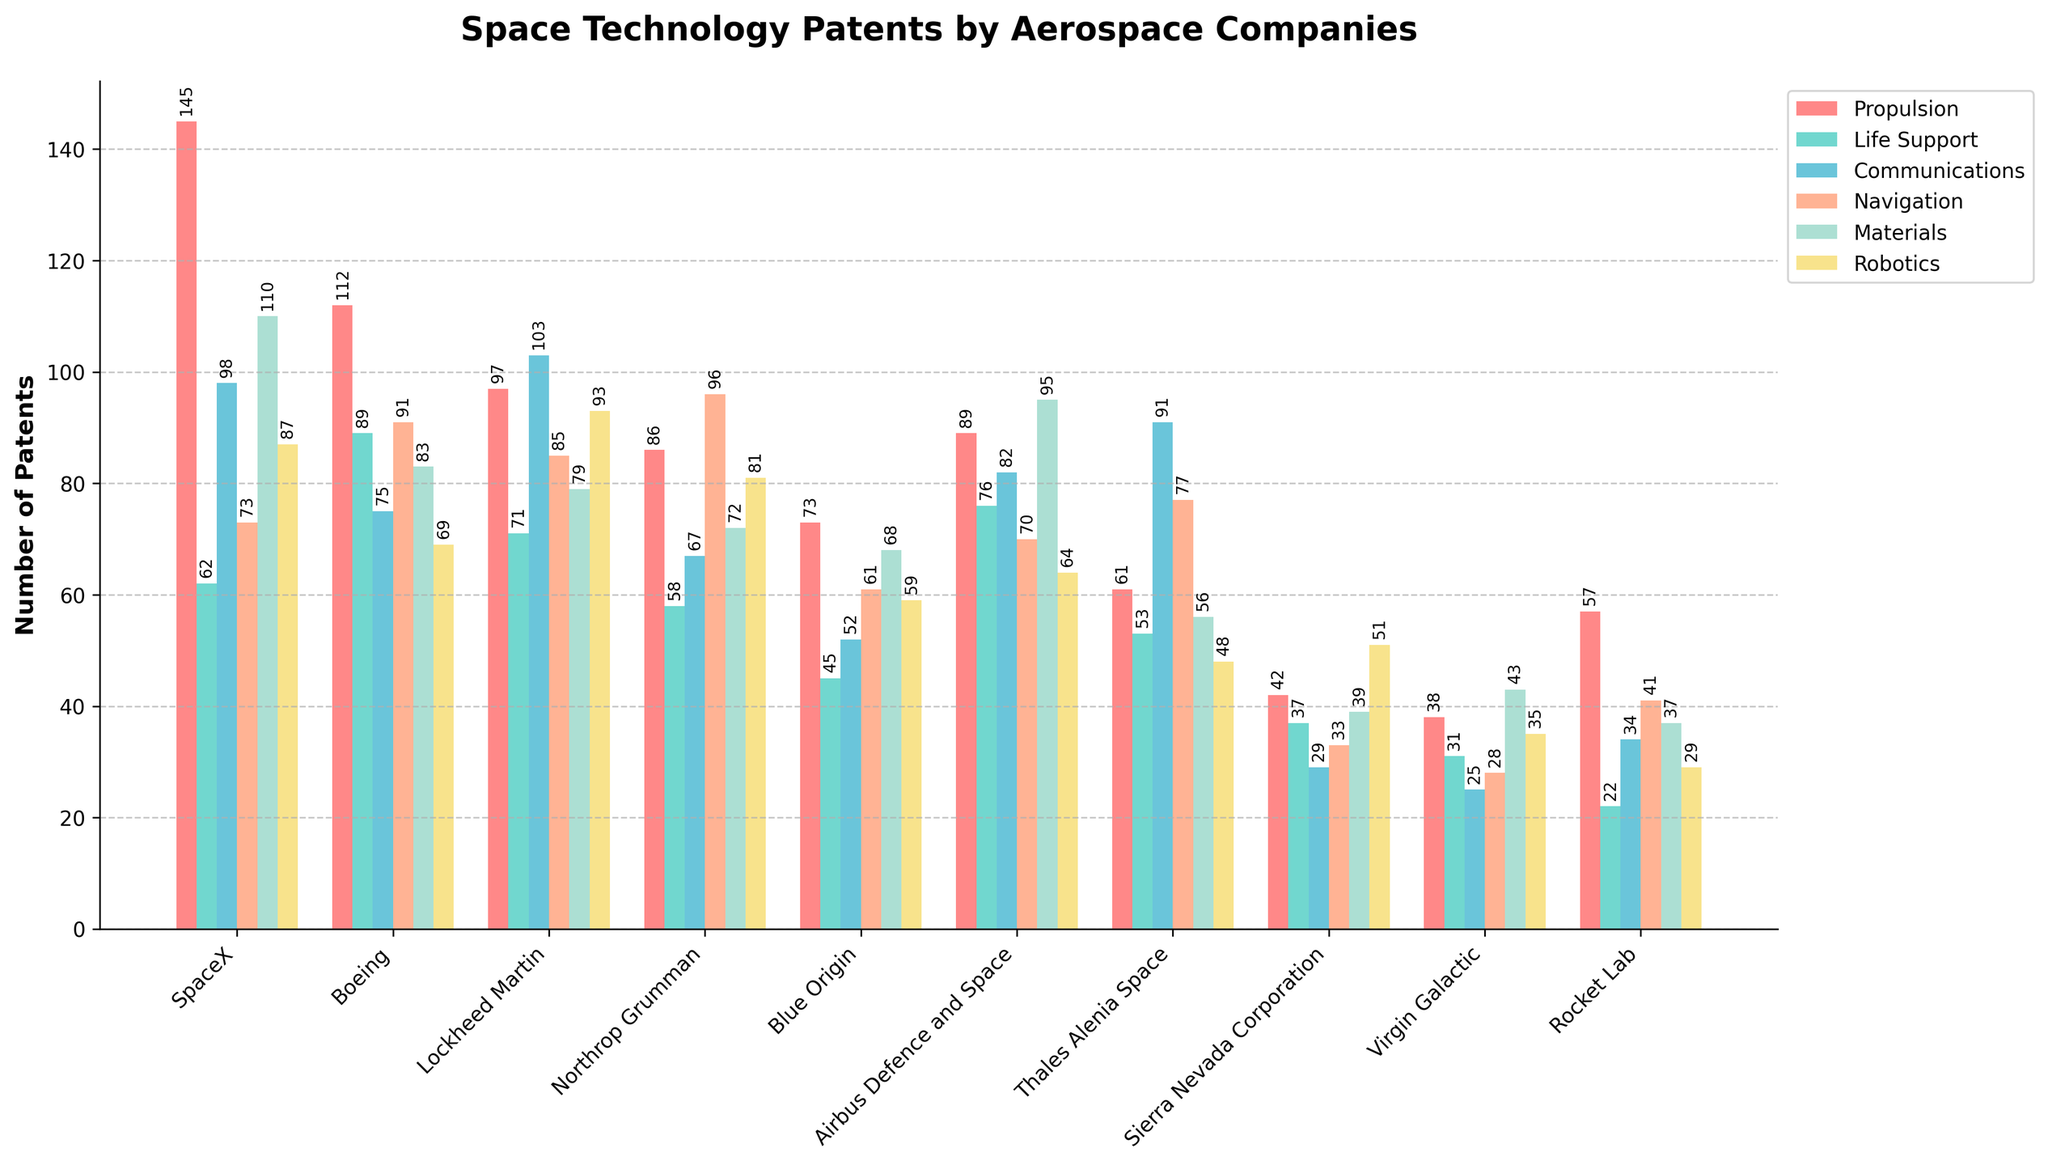What are the top two companies with the highest number of patents in the Propulsion category? Look at the heights of the bars in the Propulsion category. SpaceX has the tallest bar with 145 patents followed by Boeing with 112 patents.
Answer: SpaceX, Boeing Which company has the fewest patents in the Communications category? Look at the heights of the bars in the Communications category. Sierra Nevada Corporation has the shortest bar with 29 patents.
Answer: Sierra Nevada Corporation How many more patents does SpaceX have over Boeing in the Propulsion category? SpaceX has 145 patents and Boeing has 112 patents in the Propulsion category. The difference is 145 - 112 = 33.
Answer: 33 Which category does Lockheed Martin have the most patents in, and how many patents does it have in that category? Look at the tallest bar for Lockheed Martin. It has the most patents in the Communications category with 103 patents.
Answer: Communications, 103 What is the total number of patents filed by Thales Alenia Space in the Navigation and Materials categories combined? Thales Alenia Space has 77 patents in Navigation and 56 in Materials. The sum is 77 + 56 = 133.
Answer: 133 Which category has the overall highest number of patents across all companies? Look at the cumulative height of the bars for each category. The Propulsion category has the highest overall number of patents.
Answer: Propulsion Compare the number of Robotics patents held by SpaceX and Northrop Grumman. Which company has more and by how many? SpaceX has 87 patents and Northrop Grumman has 81 patents in the Robotics category. The difference is 87 - 81 = 6.
Answer: SpaceX, 6 Among the companies listed, which one has the closest number of patents in Life Support and Navigation categories, and what are those numbers? Compare the heights of bars in Life Support and Navigation categories for each company. Boeing has 89 patents in Life Support and 91 in Navigation, which are the closest numbers.
Answer: Boeing, Life Support: 89, Navigation: 91 What is the average number of patents in the Materials category for SpaceX, Boeing, and Lockheed Martin? Sum the number of patents in the Materials category for these three companies: 110 + 83 + 79 = 272. Divide by 3 to get the average: 272 / 3 = 90.67.
Answer: 90.67 Which company has the most diverse patent portfolio (smallest variance) across the categories listed? Calculate the variance of the number of patents for each company's categories. Considering the visual assessment for less fluctuation in bar heights, Airbus Defence and Space appears to have a balanced portfolio. To confirm, calculating the actual variance is required for a precise answer.
Answer: Airbus Defence and Space 